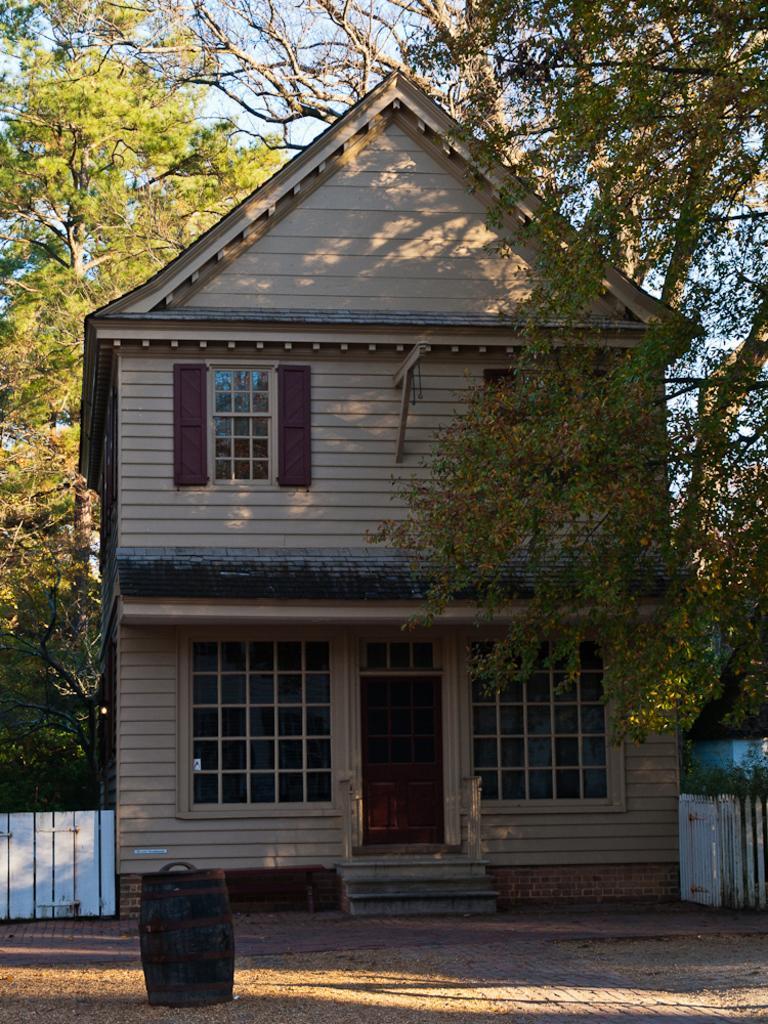Please provide a concise description of this image. This picture shows a house and we see trees and a fence and we see a barrel on the ground. 